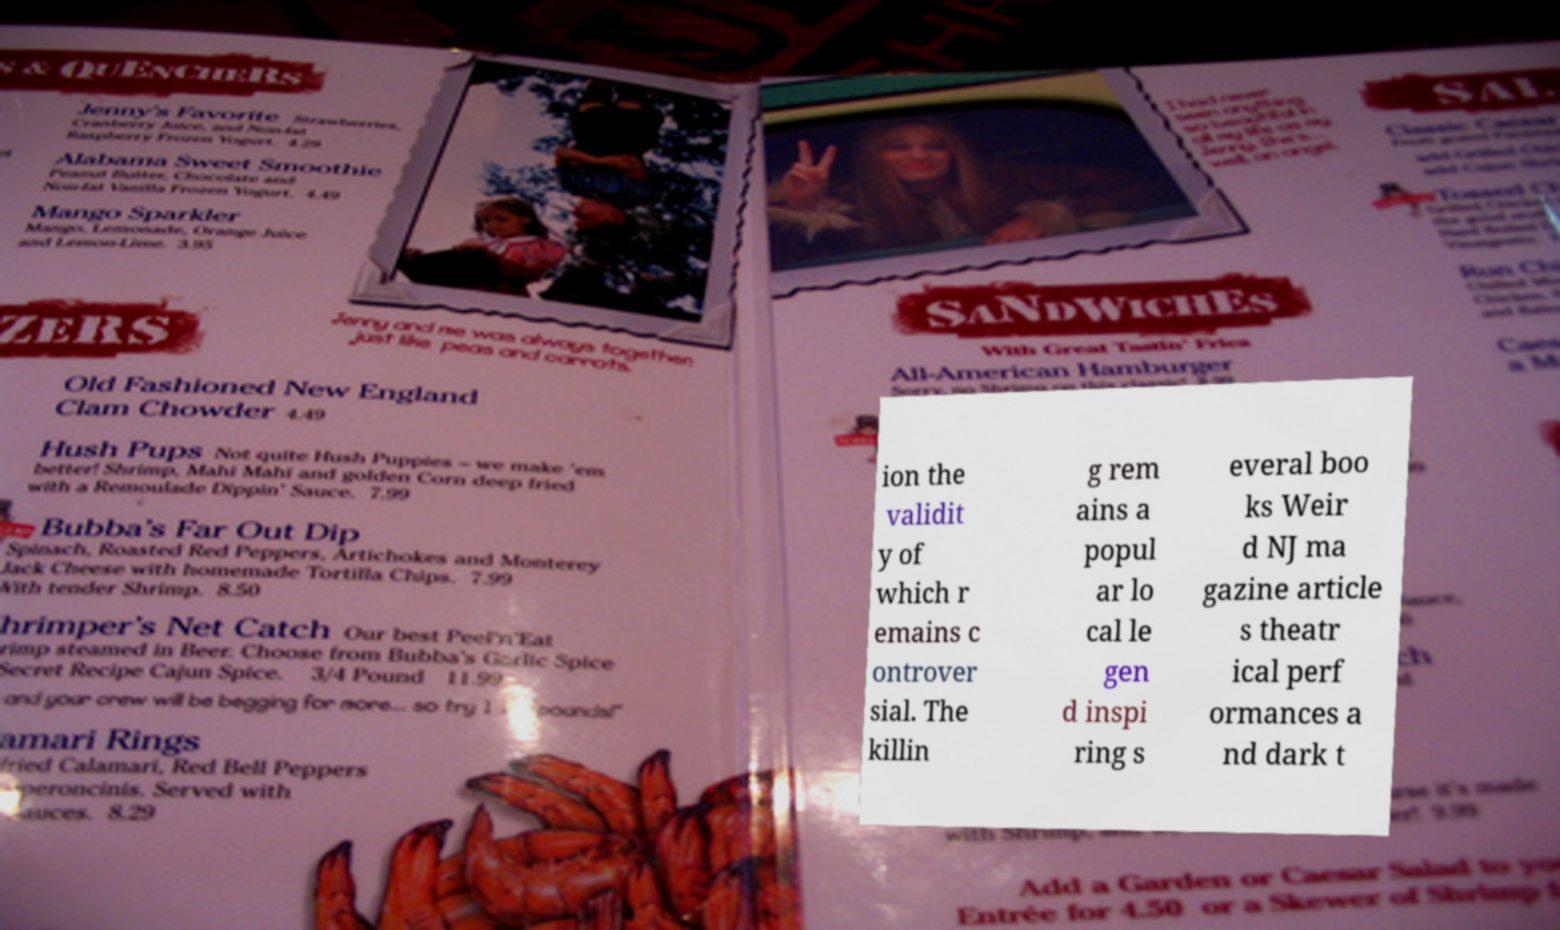Can you accurately transcribe the text from the provided image for me? ion the validit y of which r emains c ontrover sial. The killin g rem ains a popul ar lo cal le gen d inspi ring s everal boo ks Weir d NJ ma gazine article s theatr ical perf ormances a nd dark t 